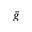Convert formula to latex. <formula><loc_0><loc_0><loc_500><loc_500>\ B a r { g }</formula> 